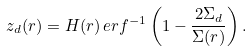Convert formula to latex. <formula><loc_0><loc_0><loc_500><loc_500>z _ { d } ( r ) = H ( r ) \, e r f ^ { - 1 } \left ( 1 - \frac { 2 \Sigma _ { d } } { \Sigma ( r ) } \right ) .</formula> 